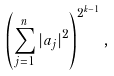<formula> <loc_0><loc_0><loc_500><loc_500>\left ( \sum _ { j = 1 } ^ { n } | a _ { j } | ^ { 2 } \right ) ^ { 2 ^ { k - 1 } } ,</formula> 